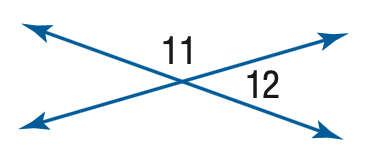Question: m \angle 11 = 4 x, m \angle 12 = 2 x - 6. Find the measure of \angle 12.
Choices:
A. 50
B. 52
C. 56
D. 62
Answer with the letter. Answer: C 